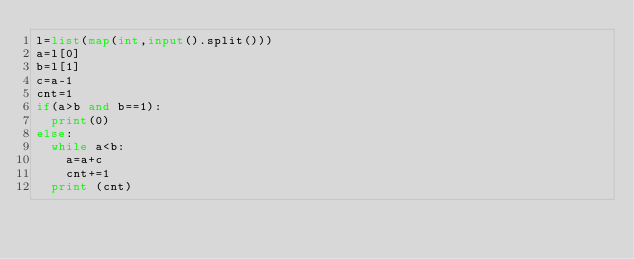Convert code to text. <code><loc_0><loc_0><loc_500><loc_500><_Python_>l=list(map(int,input().split()))
a=l[0]
b=l[1]
c=a-1
cnt=1
if(a>b and b==1):
  print(0)
else:
  while a<b:
    a=a+c
    cnt+=1
  print (cnt)</code> 